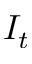<formula> <loc_0><loc_0><loc_500><loc_500>I _ { t }</formula> 